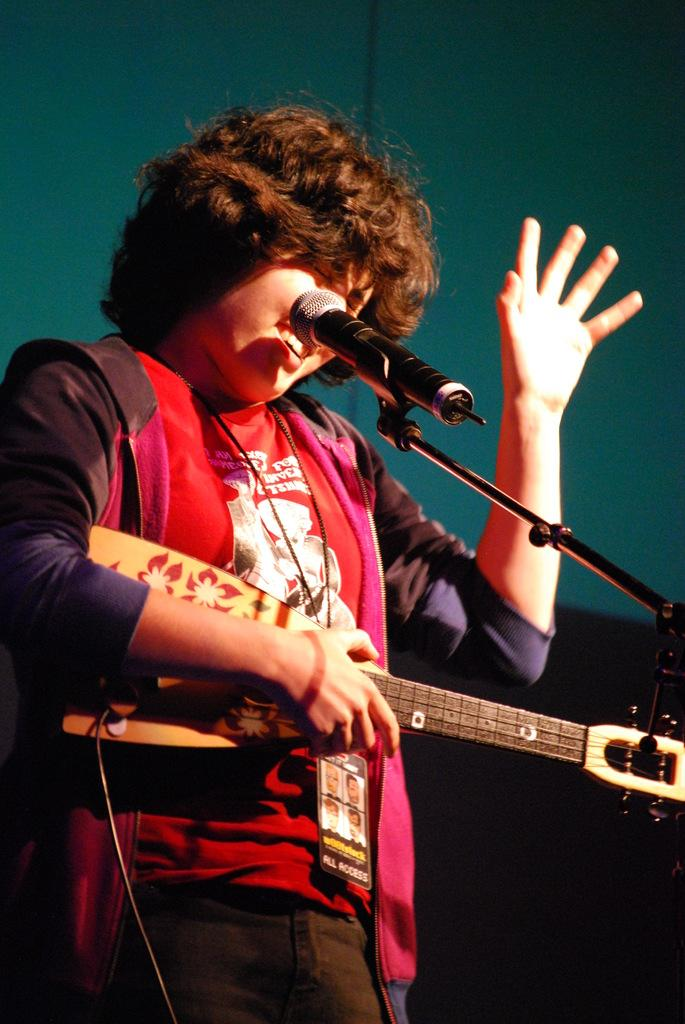What is the person in the image holding? The person is holding a guitar. What is the person's facial expression in the image? The person is smiling. What is in front of the person that might be used for amplifying sound? There is a microphone and a microphone stand in front of the person. Can you describe the person's clothing or accessories? The person is wearing a tag. What can be seen in the background of the image? There is a wall in the background of the image. What type of eye can be seen on the guitar in the image? There is no eye present on the guitar in the image. Is there a pipe visible in the image? No, there is no pipe visible in the image. 